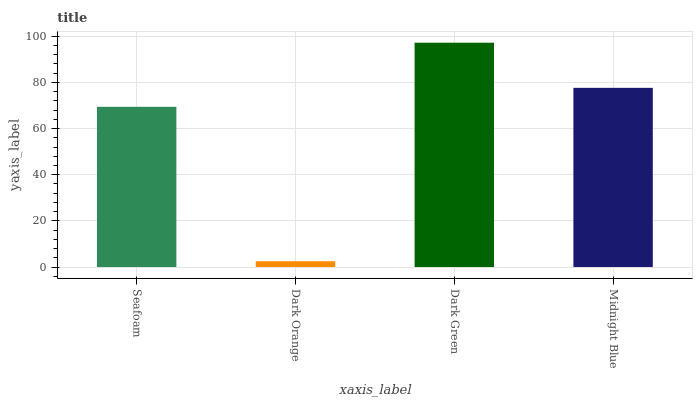Is Dark Orange the minimum?
Answer yes or no. Yes. Is Dark Green the maximum?
Answer yes or no. Yes. Is Dark Green the minimum?
Answer yes or no. No. Is Dark Orange the maximum?
Answer yes or no. No. Is Dark Green greater than Dark Orange?
Answer yes or no. Yes. Is Dark Orange less than Dark Green?
Answer yes or no. Yes. Is Dark Orange greater than Dark Green?
Answer yes or no. No. Is Dark Green less than Dark Orange?
Answer yes or no. No. Is Midnight Blue the high median?
Answer yes or no. Yes. Is Seafoam the low median?
Answer yes or no. Yes. Is Dark Orange the high median?
Answer yes or no. No. Is Dark Green the low median?
Answer yes or no. No. 